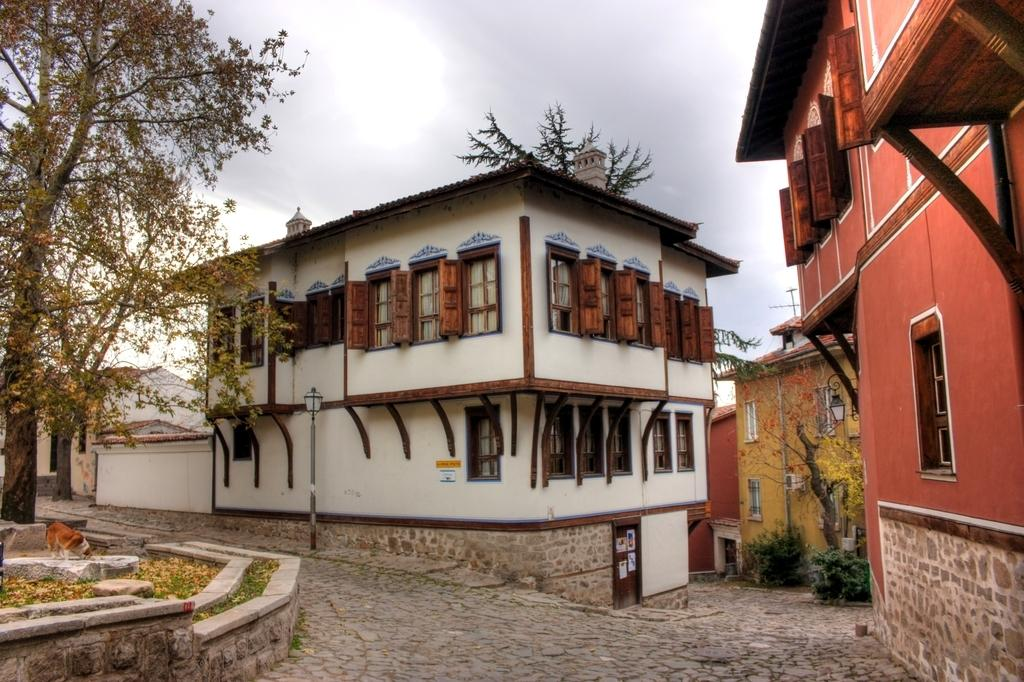What type of structures can be seen in the image? There are buildings in the image. What type of vegetation is present in the image? There are trees and plants in the image. What object can be seen standing upright in the image? There is a pole in the image. What part of the natural environment is visible in the image? The ground and the sky are visible in the image. What type of living organism can be seen in the image? There is an animal in the image. What type of grain is being used to create the string in the image? There is no grain or string present in the image. What is the animal learning in the image? The image does not depict any learning activity involving the animal. 